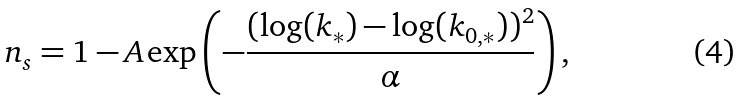<formula> <loc_0><loc_0><loc_500><loc_500>n _ { s } = 1 - A \exp \left ( - \frac { ( \log ( k _ { * } ) - \log ( k _ { 0 , * } ) ) ^ { 2 } } { \alpha } \right ) ,</formula> 